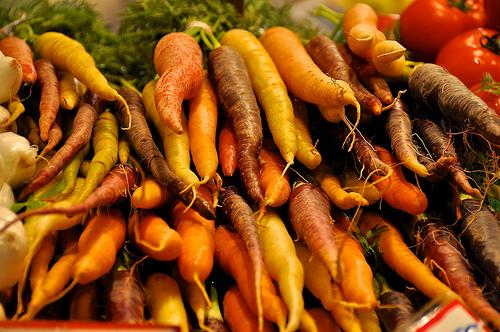Explain the focus of the image and the vegetables it contains. The main focus is the vibrant collection of multicolored carrots, accompanied by red tomatoes and white onions. Describe the interaction between the vegetables in the image. The multicolored carrots are stacked next to the red tomatoes and accompanied by white onions. Describe the color and arrangement of the carrots in the image. There are multicolored carrots, including brown, yellow, and orange, arranged in a bundle. Pretend you are describing the image to someone who cannot see it. Explain the visual details in a descriptive manner. The image features a colorful assortment of vegetables with carrots in shades of brown, yellow, and orange, nestled next to ripe red tomatoes and white onions. In a poetic way, describe the essence of the photo. Nature's bounty unraveled, a tapestry of earthy hues, with carrots of varying shades and ripe tomatoes true. Imagine yourself as an artist and describe the visual components of this image. The image exhibits a vibrant display of vegetables with multicolored carrots, ripe red tomatoes, and white onions in a delightful composition. Write a few adjectives that characterize the appearance of the carrots in the image. Fresh, colorful, and diverse with brown, yellow, and orange hues. Summarize the contents of the image in a simple sentence. Various fresh vegetables including carrots, tomatoes, and onions are displayed. What are the two vegetables that are next to the multicolored carrots? Red ripe tomatoes and white onions are next to the multicolored carrots. Mention the types of vegetables and their colors visible in the image. Brown, yellow, and orange carrots, red tomatoes, and white onions are present in the image. 